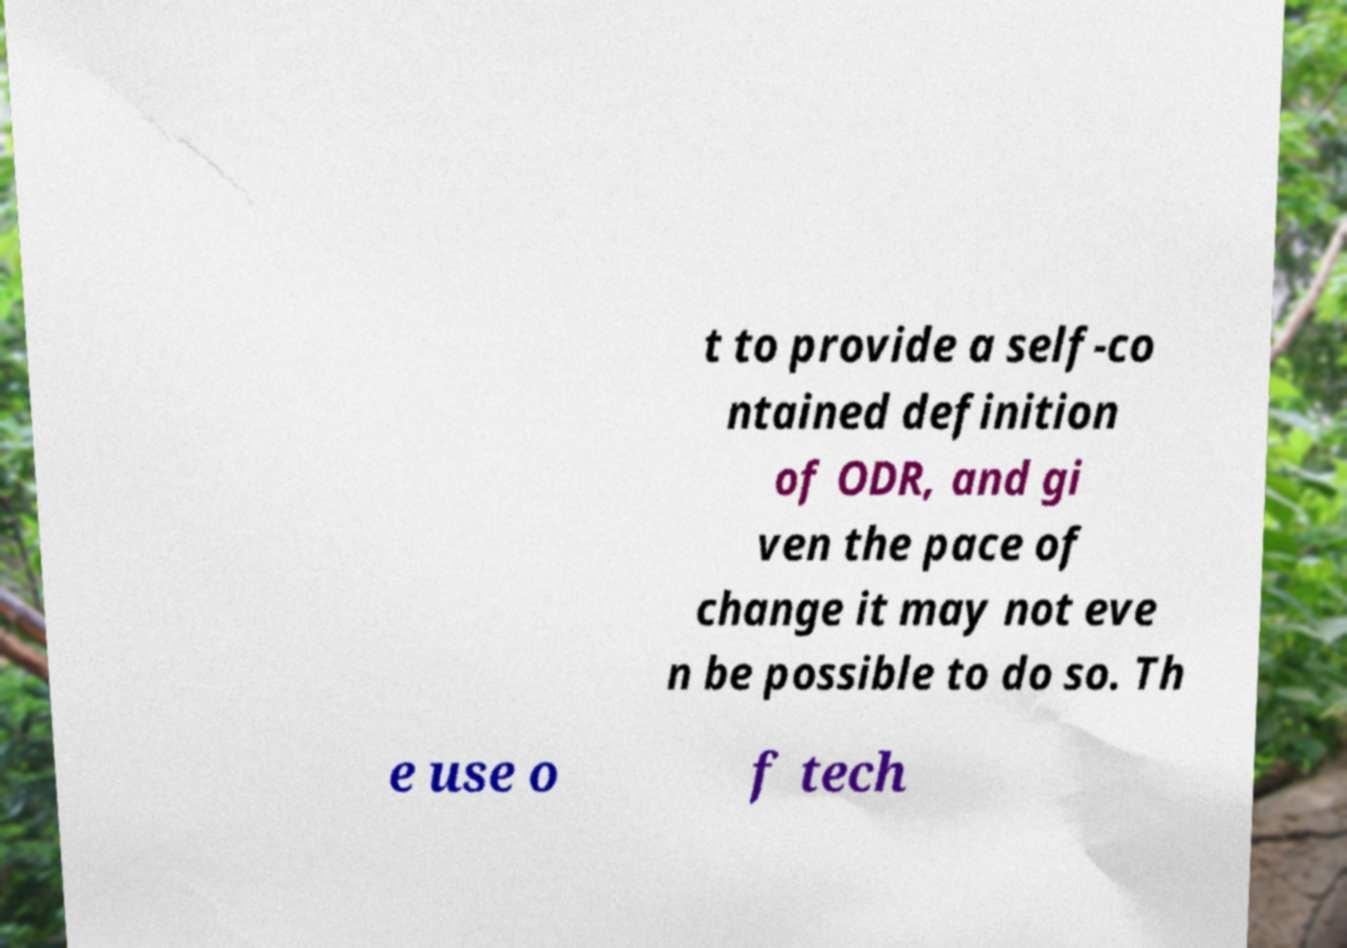Can you read and provide the text displayed in the image?This photo seems to have some interesting text. Can you extract and type it out for me? t to provide a self-co ntained definition of ODR, and gi ven the pace of change it may not eve n be possible to do so. Th e use o f tech 